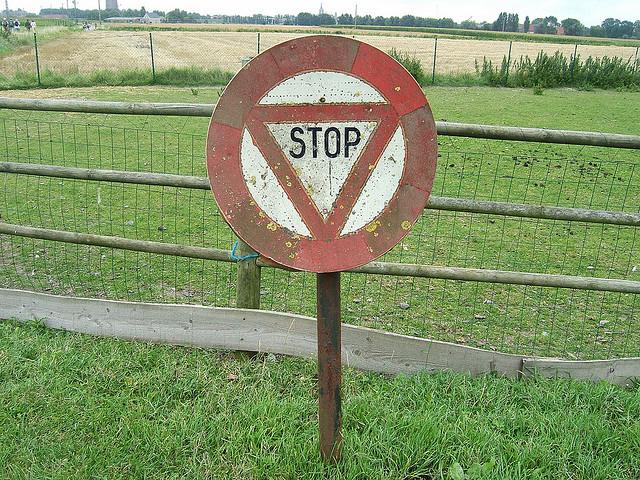Is the stop sign round?
Quick response, please. Yes. Does this stop sign need to be painted?
Quick response, please. Yes. What kind of wire is being used for fencing?
Short answer required. Chicken wire. 